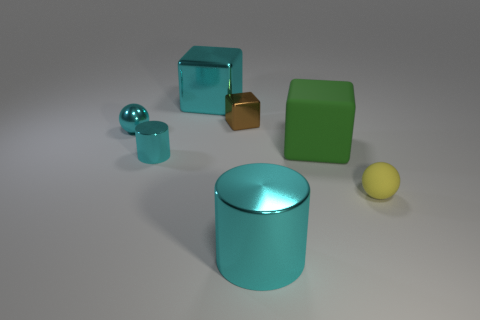What is the size of the green cube?
Make the answer very short. Large. There is a tiny brown object that is the same material as the cyan block; what is its shape?
Make the answer very short. Cube. Are there fewer small cyan shiny balls that are in front of the big shiny cylinder than large matte things?
Your response must be concise. Yes. What is the color of the small metal thing right of the big metal cube?
Provide a succinct answer. Brown. What material is the other cylinder that is the same color as the large cylinder?
Keep it short and to the point. Metal. Is there another brown shiny object that has the same shape as the tiny brown thing?
Your answer should be compact. No. How many other rubber things are the same shape as the tiny yellow matte object?
Your answer should be compact. 0. Do the large metal block and the large shiny cylinder have the same color?
Keep it short and to the point. Yes. Is the number of red blocks less than the number of brown objects?
Your answer should be very brief. Yes. There is a big object that is in front of the tiny yellow thing; what material is it?
Ensure brevity in your answer.  Metal. 